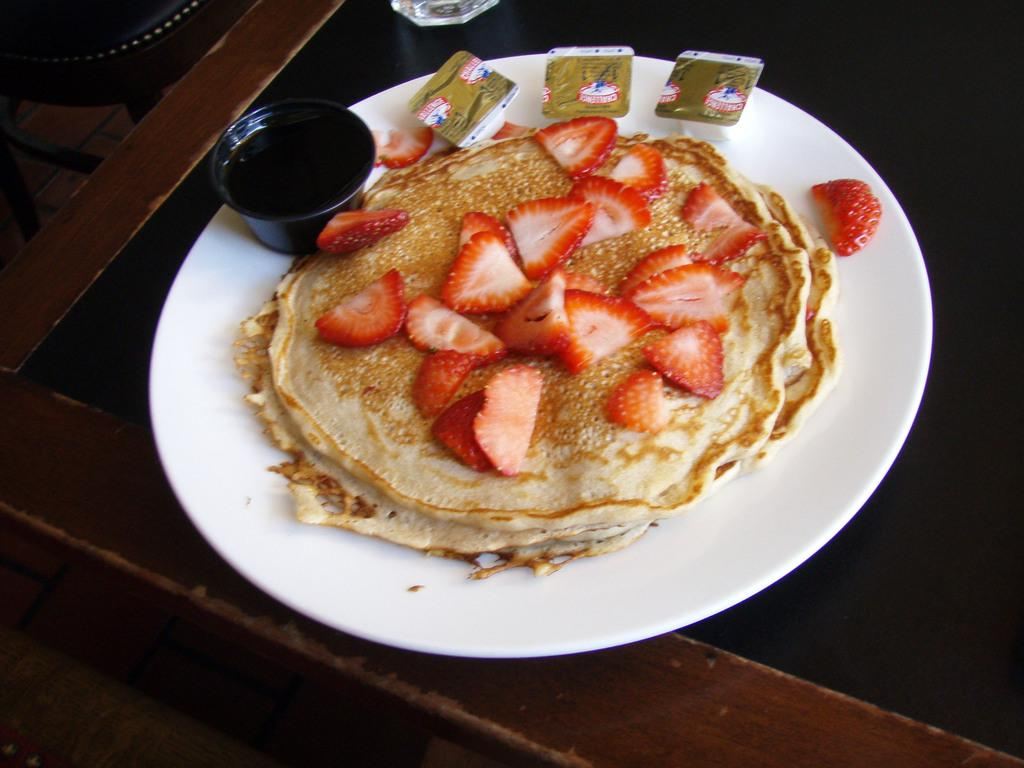What is the main piece of furniture in the image? There is a table in the image. What is placed on the table? A white color plate is placed on the table. What is on the plate? There are food items on the plate, including strawberry slices. What other container is present in the image? There is a black color bowl in the image. What is inside the black color bowl? The black color bowl contains food items. Can you see any paper floating in the sea in the image? There is no sea or paper visible in the image; it features a table with a plate and a bowl containing food items. 